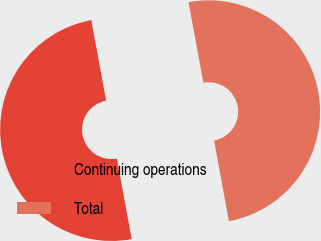Convert chart to OTSL. <chart><loc_0><loc_0><loc_500><loc_500><pie_chart><fcel>Continuing operations<fcel>Total<nl><fcel>50.0%<fcel>50.0%<nl></chart> 